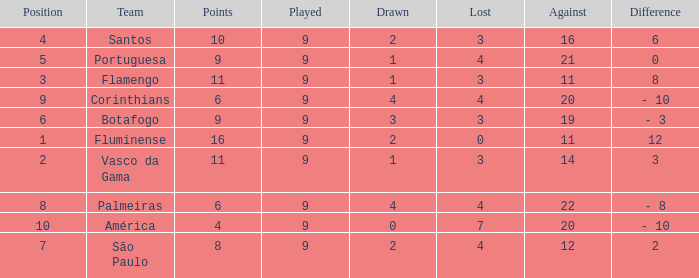Which Against is the highest one that has a Difference of 12? 11.0. 